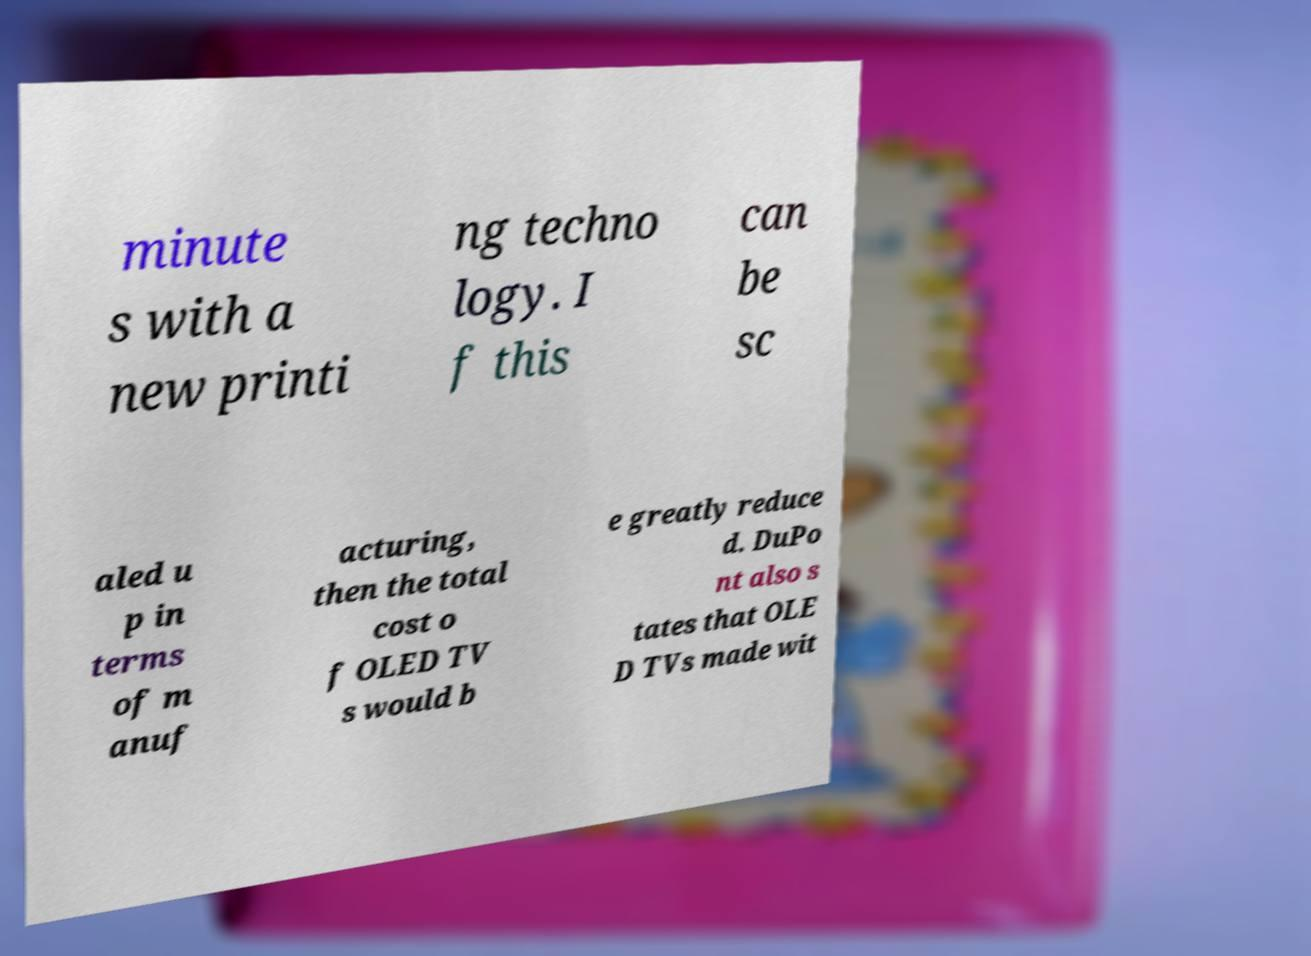What messages or text are displayed in this image? I need them in a readable, typed format. minute s with a new printi ng techno logy. I f this can be sc aled u p in terms of m anuf acturing, then the total cost o f OLED TV s would b e greatly reduce d. DuPo nt also s tates that OLE D TVs made wit 